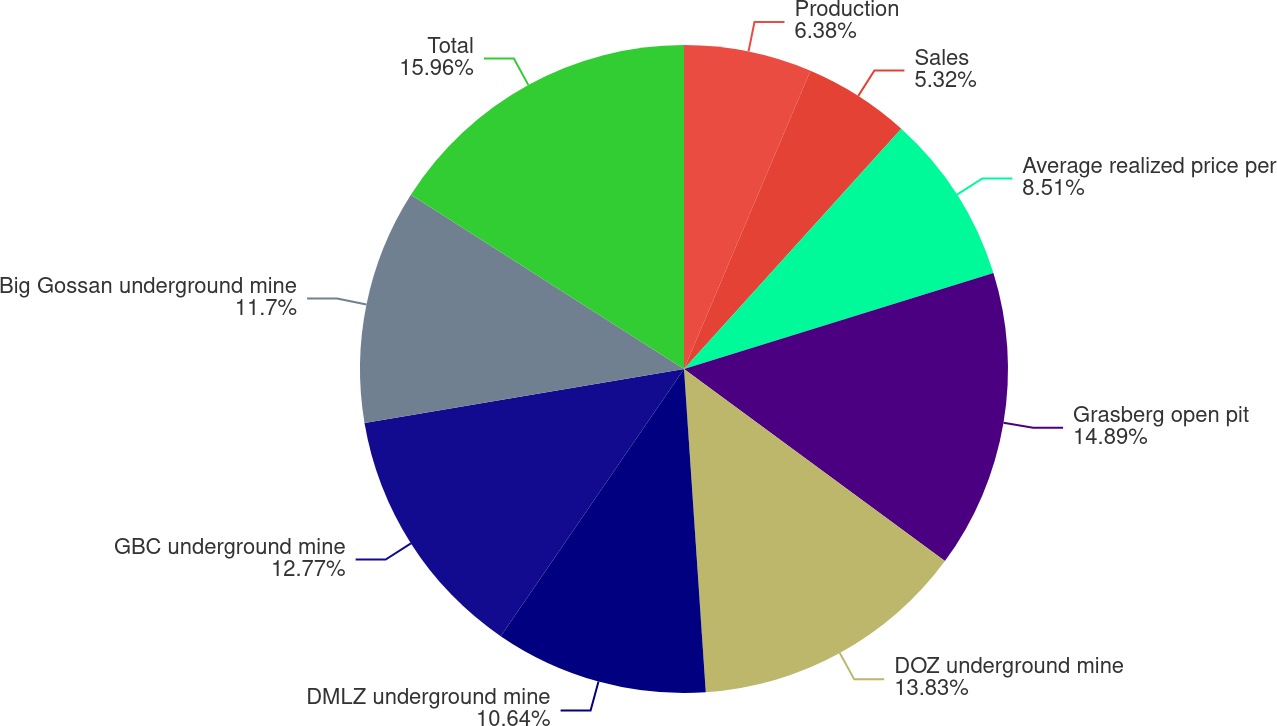Convert chart to OTSL. <chart><loc_0><loc_0><loc_500><loc_500><pie_chart><fcel>Production<fcel>Sales<fcel>Average realized price per<fcel>Grasberg open pit<fcel>DOZ underground mine<fcel>DMLZ underground mine<fcel>GBC underground mine<fcel>Big Gossan underground mine<fcel>Total<nl><fcel>6.38%<fcel>5.32%<fcel>8.51%<fcel>14.89%<fcel>13.83%<fcel>10.64%<fcel>12.77%<fcel>11.7%<fcel>15.96%<nl></chart> 